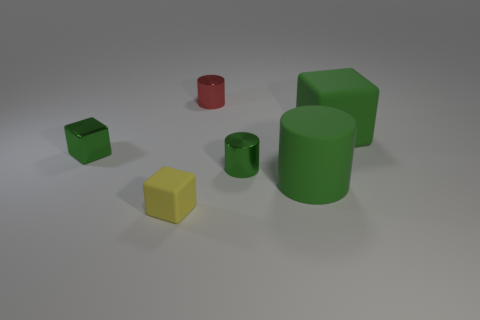Add 2 green shiny cylinders. How many objects exist? 8 Subtract all brown cubes. Subtract all tiny metal objects. How many objects are left? 3 Add 6 small shiny blocks. How many small shiny blocks are left? 7 Add 5 small gray metallic cylinders. How many small gray metallic cylinders exist? 5 Subtract 0 gray spheres. How many objects are left? 6 